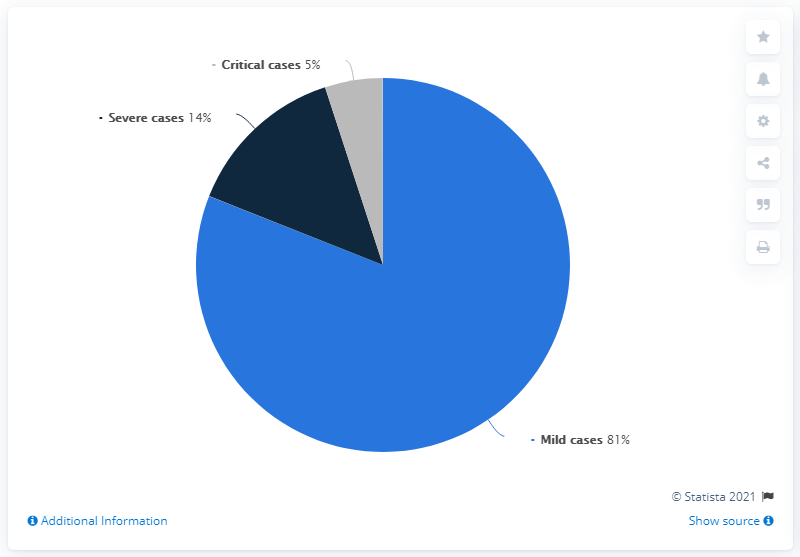Draw attention to some important aspects in this diagram. The ratio between mild and severe cases is 5.786... In a pie chart, three colors were used, and the percentage of blue color was 81%. 